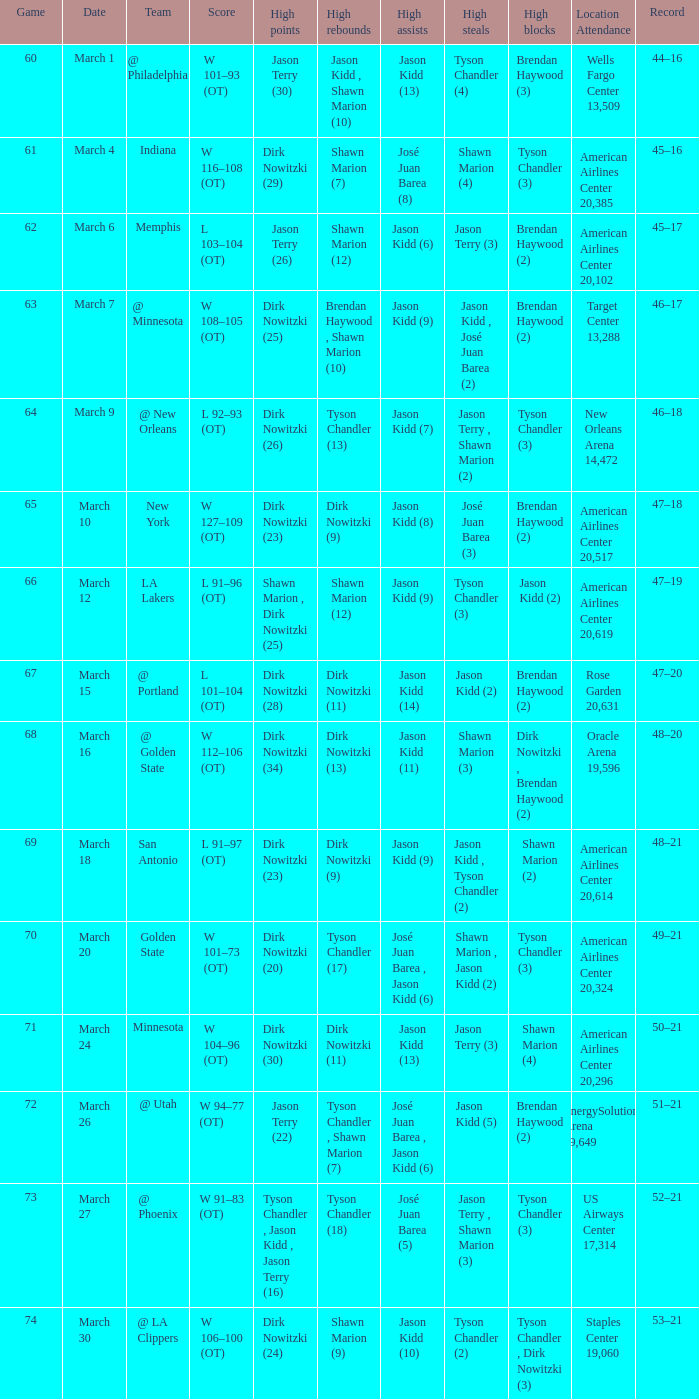Name the high assists for  l 103–104 (ot) Jason Kidd (6). 